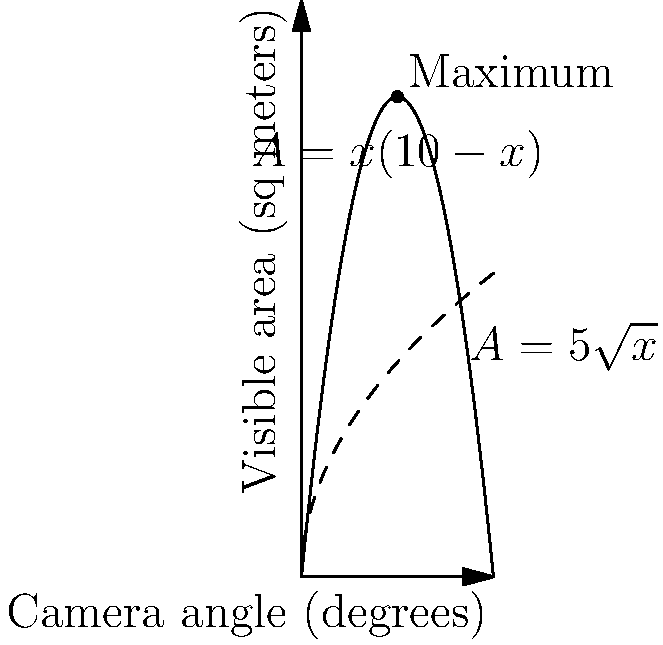As an aspiring filmmaker, you're setting up a shot for your latest project. The visible area (A) in your scene depends on the camera angle (x) according to two functions: $A = x(10-x)$ for angles between 0° and 10°, and $A = 5\sqrt{x}$ for angles greater than 10°. What camera angle should you choose to maximize the visible area in your shot, and what is the maximum visible area? Round your answers to two decimal places. To solve this optimization problem, we need to follow these steps:

1) First, let's find the maximum of $A = x(10-x)$ for $0 \leq x \leq 10$:
   - Expand the equation: $A = 10x - x^2$
   - Find the derivative: $\frac{dA}{dx} = 10 - 2x$
   - Set the derivative to zero: $10 - 2x = 0$
   - Solve for x: $x = 5$
   - The second derivative is negative, confirming this is a maximum

2) Now, let's find the maximum of $A = 5\sqrt{x}$ for $x > 10$:
   - Find the derivative: $\frac{dA}{dx} = \frac{5}{2\sqrt{x}}$
   - This is always positive for $x > 0$, so the function increases indefinitely

3) Compare the two results:
   - For $A = x(10-x)$, the maximum occurs at $x = 5$, giving $A = 5(10-5) = 25$ sq meters
   - For $A = 5\sqrt{x}$, the value at $x = 10$ is $A = 5\sqrt{10} \approx 15.81$ sq meters, which is less than 25

4) Therefore, the overall maximum occurs at $x = 5$ degrees, with a visible area of 25 sq meters.
Answer: 5.00°, 25.00 sq meters 